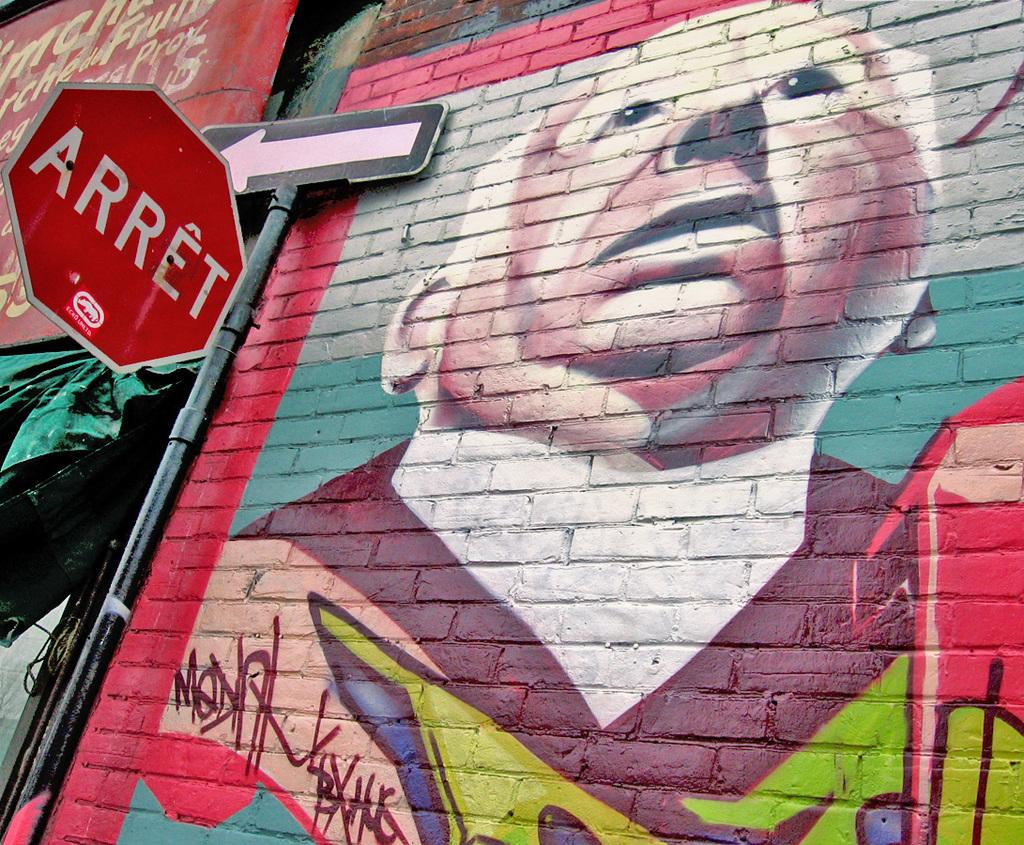Provide a one-sentence caption for the provided image. On a one-way street in a foreign land, STOP signs read "ARRET.". 